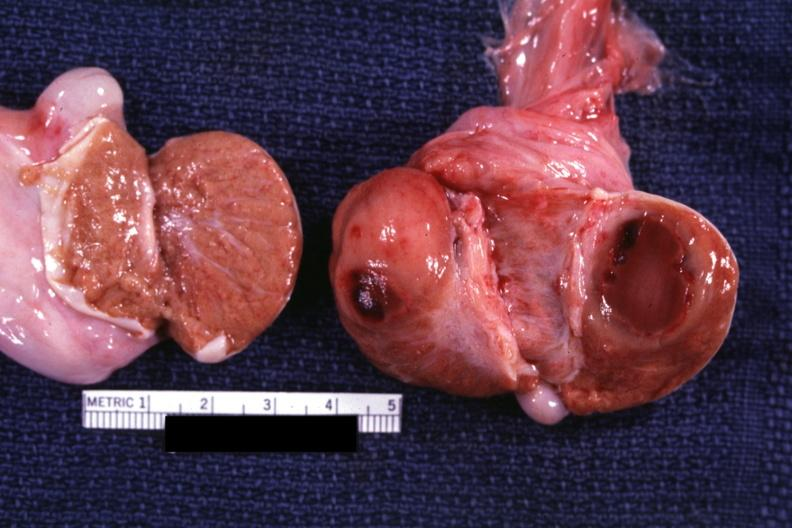what does this image show?
Answer the question using a single word or phrase. Cut surface with round tumor mass and large area central necrosis chronic granulocytic leukemia 